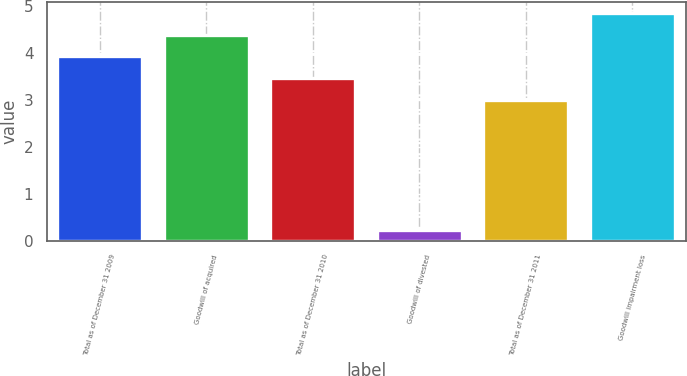Convert chart to OTSL. <chart><loc_0><loc_0><loc_500><loc_500><bar_chart><fcel>Total as of December 31 2009<fcel>Goodwill of acquired<fcel>Total as of December 31 2010<fcel>Goodwill of divested<fcel>Total as of December 31 2011<fcel>Goodwill impairment loss<nl><fcel>3.92<fcel>4.38<fcel>3.46<fcel>0.23<fcel>3<fcel>4.84<nl></chart> 